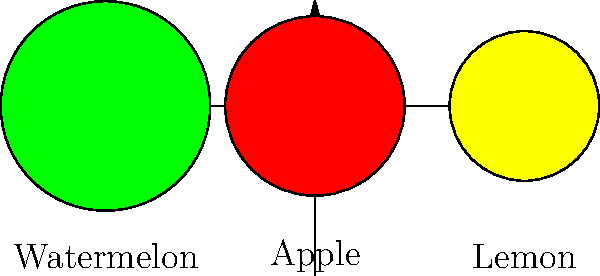Your cousin, an international student at Del Mar College, is working on a machine learning project to classify fruits. Based on the image, which feature would be most effective for distinguishing between a lemon and an apple using a simple decision tree classifier? To answer this question, let's analyze the characteristics of the fruits shown in the image:

1. Apple:
   - Shape: Circular
   - Color: Red
   - Size: Medium

2. Lemon:
   - Shape: Slightly oval
   - Color: Yellow
   - Size: Smaller than the apple

3. Watermelon:
   - Shape: Circular
   - Color: Green
   - Size: Larger than both apple and lemon

When comparing the apple and lemon specifically:

a) Shape: Both are roughly circular, with the lemon being slightly oval. This difference is subtle and may not be the most reliable feature for classification.

b) Size: There is a small difference in size, but it might not be consistent across all samples of apples and lemons.

c) Color: This is the most distinct difference between the two fruits. The apple is clearly red, while the lemon is yellow.

For a simple decision tree classifier, using a single feature that provides clear separation between classes is most effective. In this case, the color provides the most obvious distinction between apples and lemons.

Therefore, the color would be the most effective feature for distinguishing between a lemon and an apple using a simple decision tree classifier.
Answer: Color 